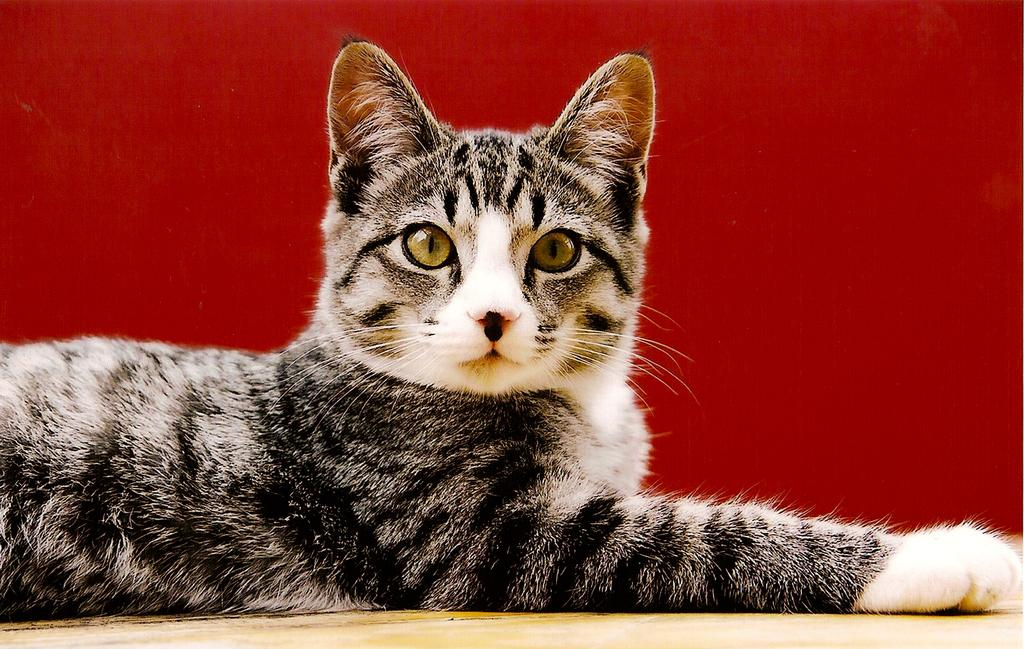What type of animal is in the image? There is a cat in the image. What can be seen beneath the cat? The ground is visible in the image. What color is the background of the image? The background of the image is red. What type of fruit is hanging from the cave in the image? There is no cave or fruit present in the image. 